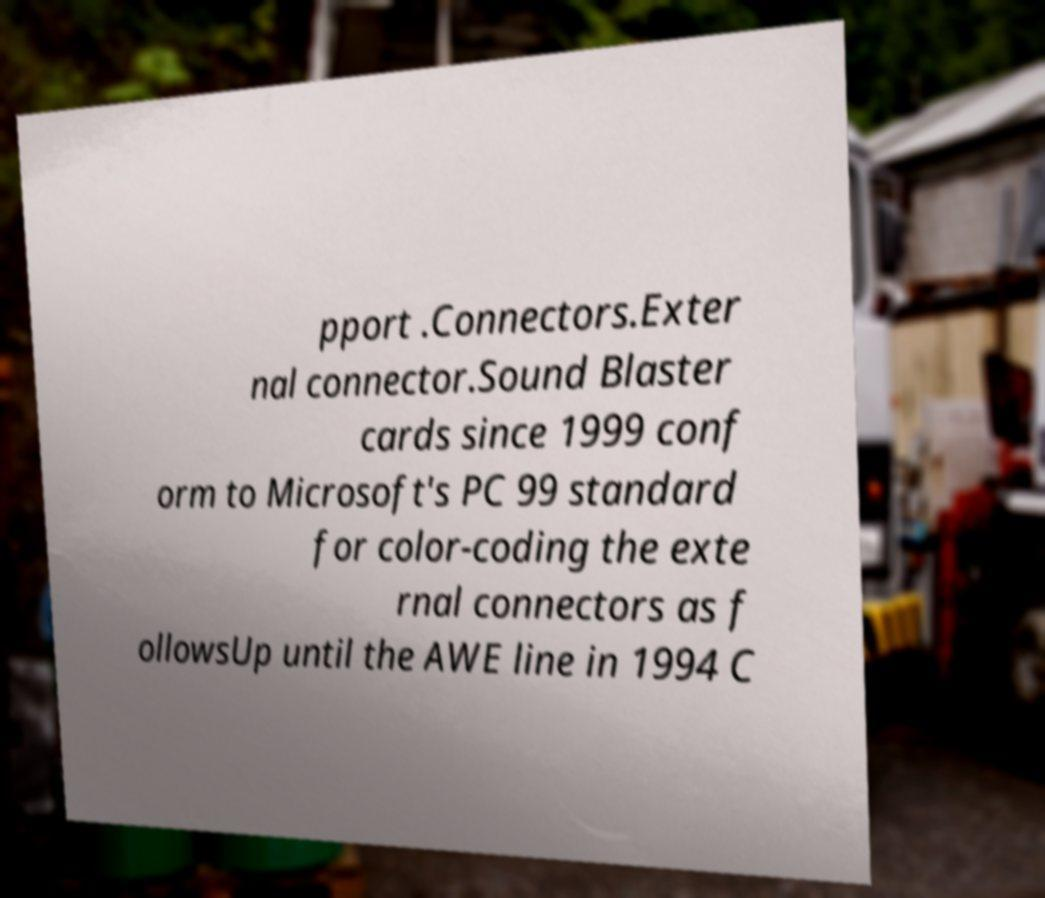Please read and relay the text visible in this image. What does it say? pport .Connectors.Exter nal connector.Sound Blaster cards since 1999 conf orm to Microsoft's PC 99 standard for color-coding the exte rnal connectors as f ollowsUp until the AWE line in 1994 C 